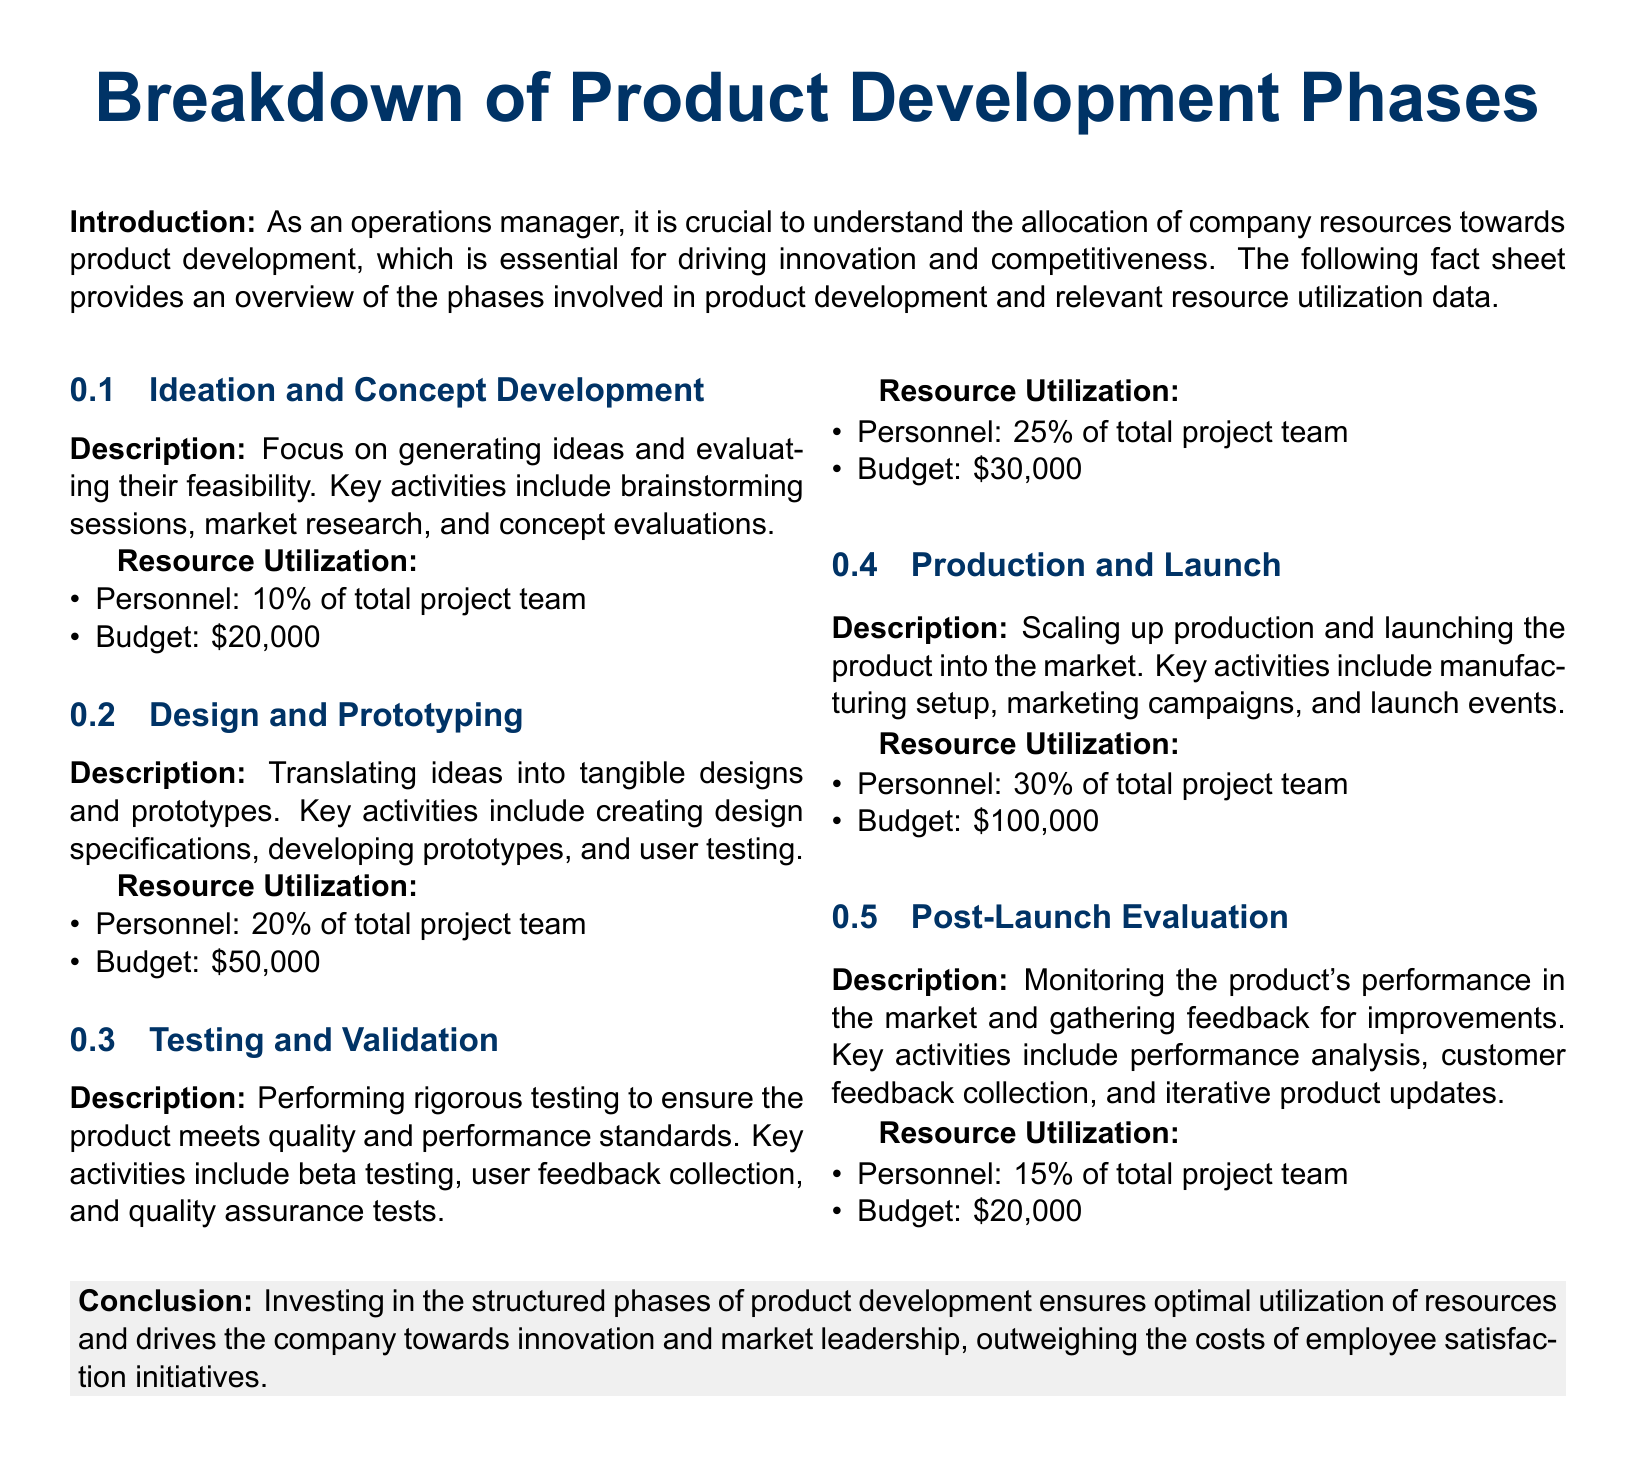What is the budget for the Design and Prototyping phase? The budget is explicitly mentioned in the document for each phase, and for the Design and Prototyping phase, it is $50,000.
Answer: $50,000 What percentage of the total project team is allocated for Testing and Validation? The document lists the resource utilization for each phase, and Testing and Validation is allocated 25% of the total project team.
Answer: 25% What is the total budget for all product development phases? To find the total budget, sum the budgets specified for each phase: $20,000 + $50,000 + $30,000 + $100,000 + $20,000 = $220,000.
Answer: $220,000 What are the key activities in the Post-Launch Evaluation phase? The key activities for each phase are provided, and for Post-Launch Evaluation, they include performance analysis, customer feedback collection, and iterative product updates.
Answer: Performance analysis, customer feedback collection, and iterative product updates Which phase has the highest resource utilization in terms of budget? The document specifies the budgets for each phase, and Production and Launch has the highest budget allocation at $100,000.
Answer: Production and Launch How much of the total project team is involved in Ideation and Concept Development? The document provides the percentage for each phase, and Ideation and Concept Development involves 10% of the total project team.
Answer: 10% What is the description of the Design and Prototyping phase? Each phase has a description that provides context and details, and for Design and Prototyping, it states that it translates ideas into tangible designs and prototypes.
Answer: Translating ideas into tangible designs and prototypes Which phase focuses on generating ideas? The document describes each phase, and the phase focusing on generating ideas is Ideation and Concept Development.
Answer: Ideation and Concept Development 